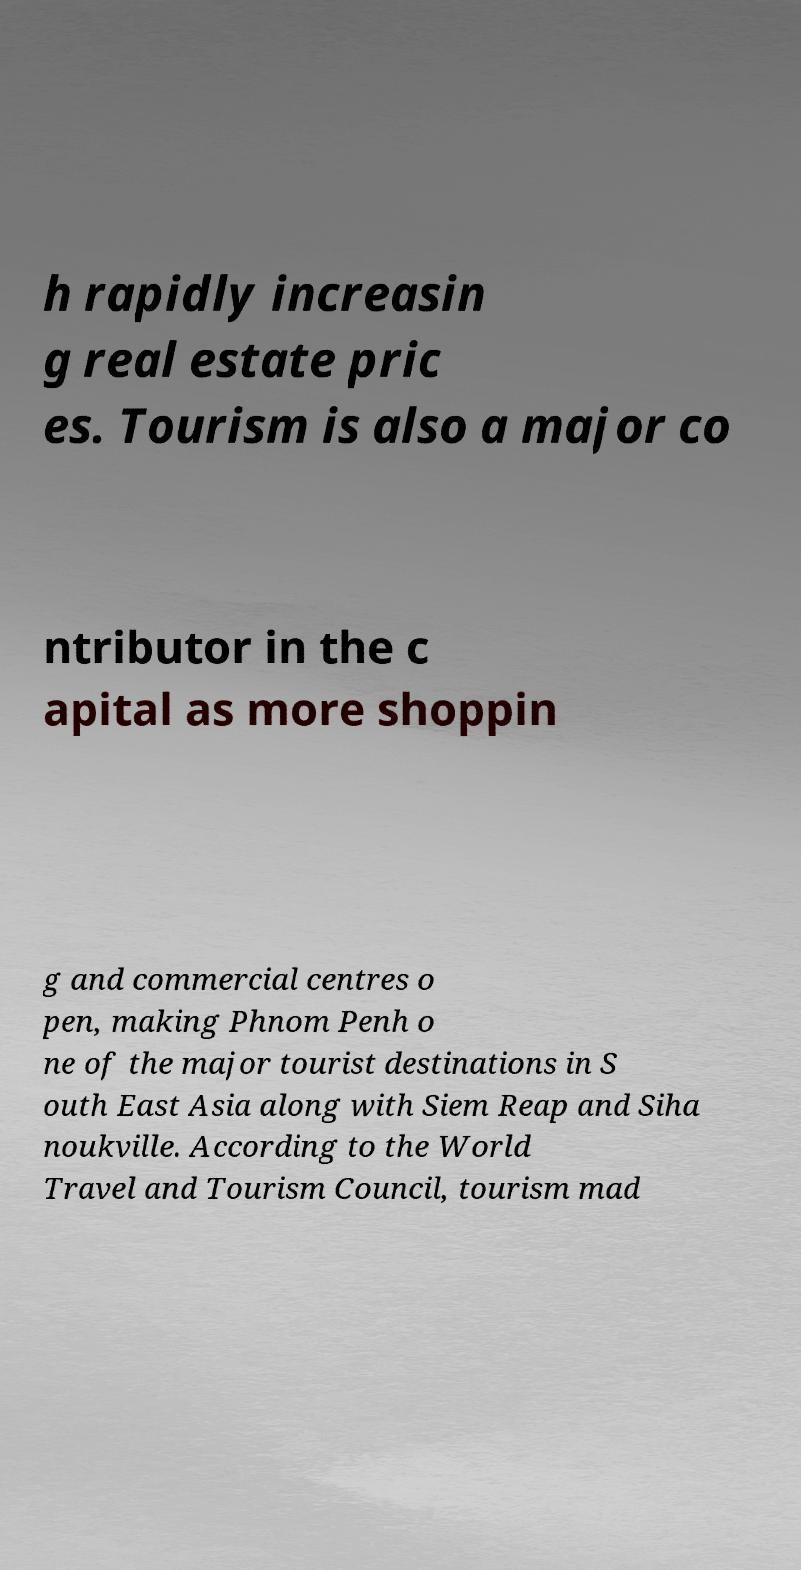What messages or text are displayed in this image? I need them in a readable, typed format. h rapidly increasin g real estate pric es. Tourism is also a major co ntributor in the c apital as more shoppin g and commercial centres o pen, making Phnom Penh o ne of the major tourist destinations in S outh East Asia along with Siem Reap and Siha noukville. According to the World Travel and Tourism Council, tourism mad 